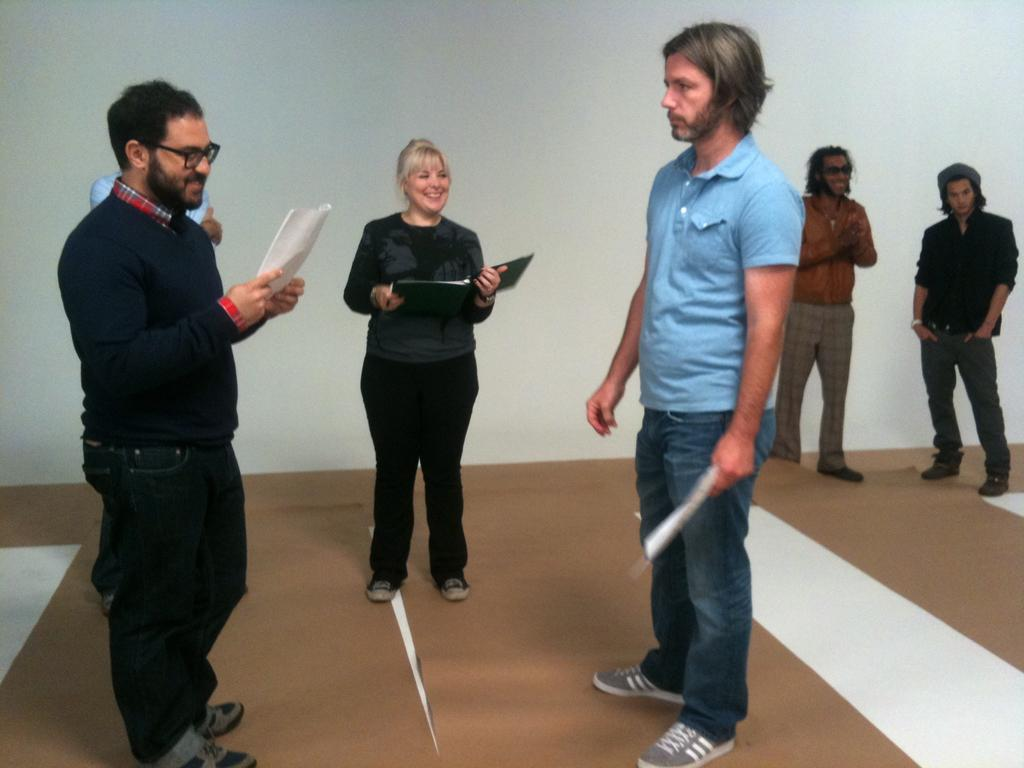What can be seen in the image? There is a group of people in the image. What are some of the people doing in the image? Some people are holding objects, and some are smiling. What is visible in the background of the image? There is a wall in the background of the image. What time of day is the event taking place in the image? There is no specific event mentioned in the image, and the time of day cannot be determined from the provided facts. What type of stew is being served at the gathering in the image? There is no mention of any food, including stew, in the image. 